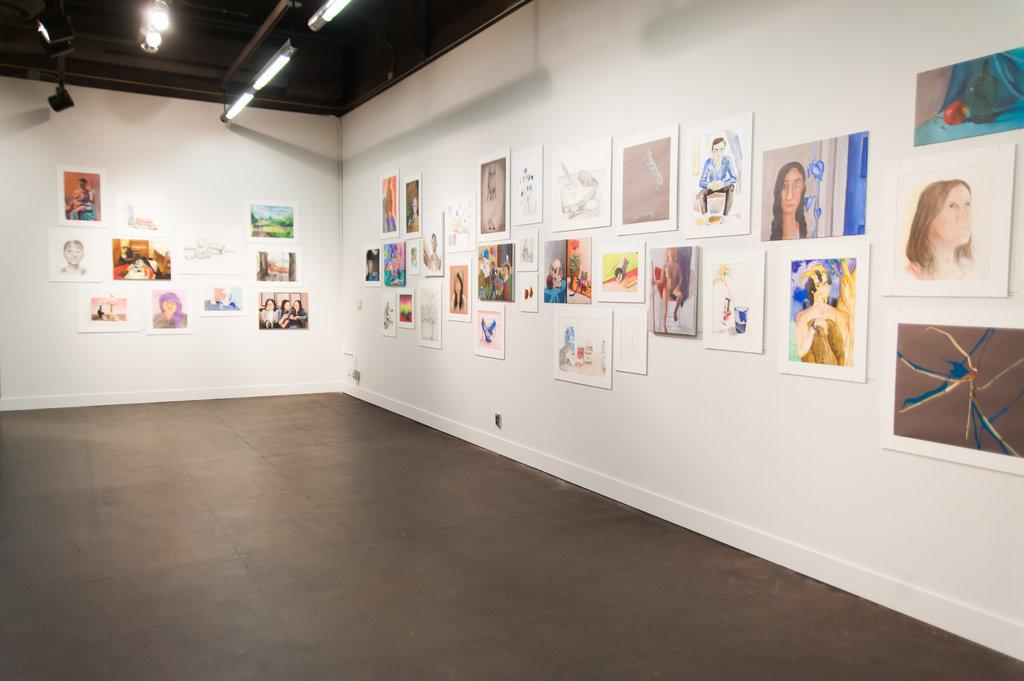What type of decorations can be seen on the walls in the image? There are wall hangings in the image. How are the wall hangings secured to the walls? The wall hangings are attached to the walls. What type of lighting is present in the image? There are electric lights in the image. Are there any plants growing along the border of the room in the image? There is no mention of plants or borders in the image; it only features wall hangings and electric lights. 